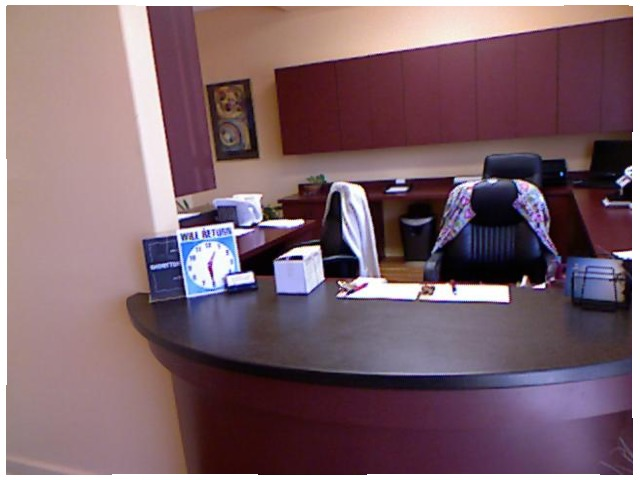<image>
Is there a table in front of the chair? Yes. The table is positioned in front of the chair, appearing closer to the camera viewpoint. Is the chair behind the desk? Yes. From this viewpoint, the chair is positioned behind the desk, with the desk partially or fully occluding the chair. Is the shirt behind the chair? Yes. From this viewpoint, the shirt is positioned behind the chair, with the chair partially or fully occluding the shirt. Is the clock behind the buiness cards? Yes. From this viewpoint, the clock is positioned behind the buiness cards, with the buiness cards partially or fully occluding the clock. 